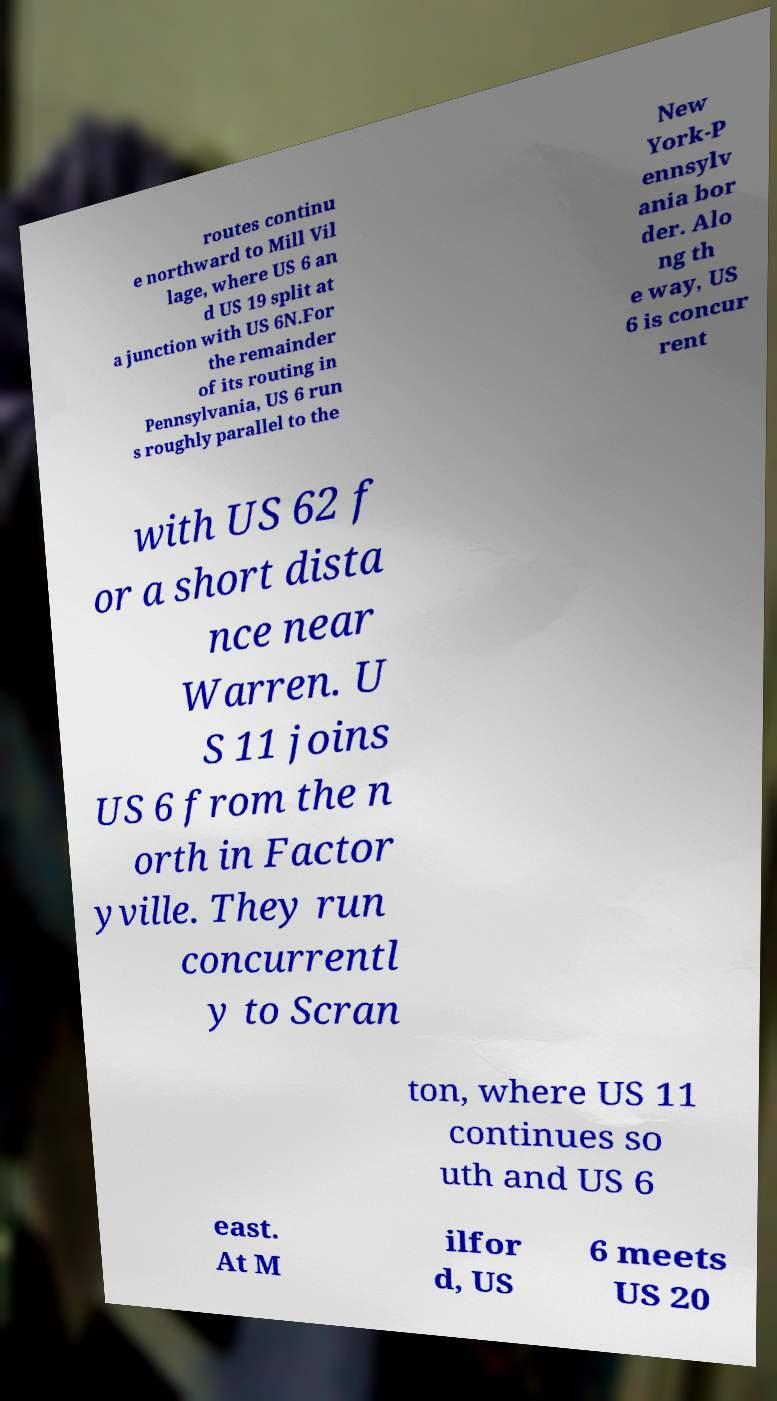Please identify and transcribe the text found in this image. routes continu e northward to Mill Vil lage, where US 6 an d US 19 split at a junction with US 6N.For the remainder of its routing in Pennsylvania, US 6 run s roughly parallel to the New York-P ennsylv ania bor der. Alo ng th e way, US 6 is concur rent with US 62 f or a short dista nce near Warren. U S 11 joins US 6 from the n orth in Factor yville. They run concurrentl y to Scran ton, where US 11 continues so uth and US 6 east. At M ilfor d, US 6 meets US 20 